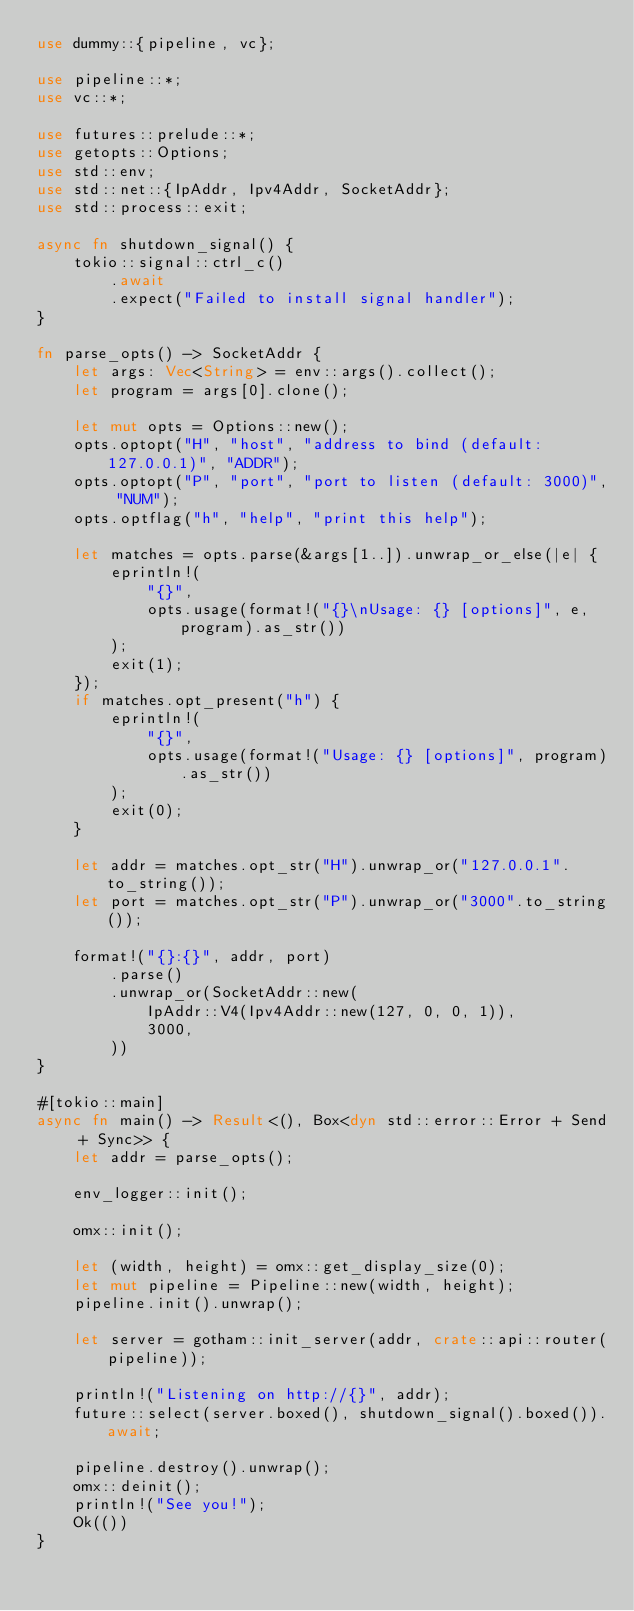<code> <loc_0><loc_0><loc_500><loc_500><_Rust_>use dummy::{pipeline, vc};

use pipeline::*;
use vc::*;

use futures::prelude::*;
use getopts::Options;
use std::env;
use std::net::{IpAddr, Ipv4Addr, SocketAddr};
use std::process::exit;

async fn shutdown_signal() {
    tokio::signal::ctrl_c()
        .await
        .expect("Failed to install signal handler");
}

fn parse_opts() -> SocketAddr {
    let args: Vec<String> = env::args().collect();
    let program = args[0].clone();

    let mut opts = Options::new();
    opts.optopt("H", "host", "address to bind (default: 127.0.0.1)", "ADDR");
    opts.optopt("P", "port", "port to listen (default: 3000)", "NUM");
    opts.optflag("h", "help", "print this help");

    let matches = opts.parse(&args[1..]).unwrap_or_else(|e| {
        eprintln!(
            "{}",
            opts.usage(format!("{}\nUsage: {} [options]", e, program).as_str())
        );
        exit(1);
    });
    if matches.opt_present("h") {
        eprintln!(
            "{}",
            opts.usage(format!("Usage: {} [options]", program).as_str())
        );
        exit(0);
    }

    let addr = matches.opt_str("H").unwrap_or("127.0.0.1".to_string());
    let port = matches.opt_str("P").unwrap_or("3000".to_string());

    format!("{}:{}", addr, port)
        .parse()
        .unwrap_or(SocketAddr::new(
            IpAddr::V4(Ipv4Addr::new(127, 0, 0, 1)),
            3000,
        ))
}

#[tokio::main]
async fn main() -> Result<(), Box<dyn std::error::Error + Send + Sync>> {
    let addr = parse_opts();

    env_logger::init();

    omx::init();

    let (width, height) = omx::get_display_size(0);
    let mut pipeline = Pipeline::new(width, height);
    pipeline.init().unwrap();

    let server = gotham::init_server(addr, crate::api::router(pipeline));

    println!("Listening on http://{}", addr);
    future::select(server.boxed(), shutdown_signal().boxed()).await;

    pipeline.destroy().unwrap();
    omx::deinit();
    println!("See you!");
    Ok(())
}
</code> 